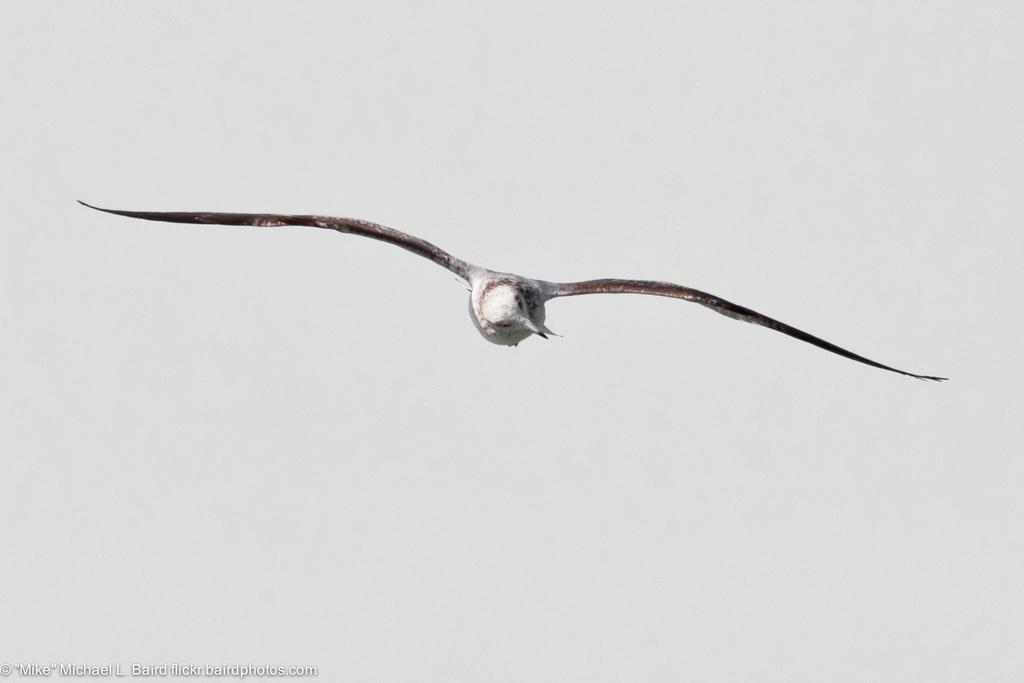What type of animal is in the image? There is a bird in the image. What is the bird doing in the image? The bird is flying in the air. Can you describe the bird's appearance? The bird has white and brown colors. What can be seen in the background of the image? The sky is visible in the background of the image. What is the color of the sky in the image? The sky is white in color. Is there a cart made of wax in the image? No, there is no cart made of wax in the image. Can the bird be seen walking through quicksand in the image? No, the bird is flying in the air, not walking through quicksand. 